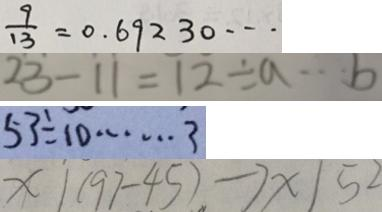Convert formula to latex. <formula><loc_0><loc_0><loc_500><loc_500>\frac { 9 } { 1 3 } = 0 . 6 9 2 3 0 \cdots 
 2 3 - 1 1 = 1 2 \div a \cdots b 
 5 3 \div 1 0 \cdots 3 
 x \vert ( 9 7 - 4 5 ) \rightarrow x \vert 5 2</formula> 